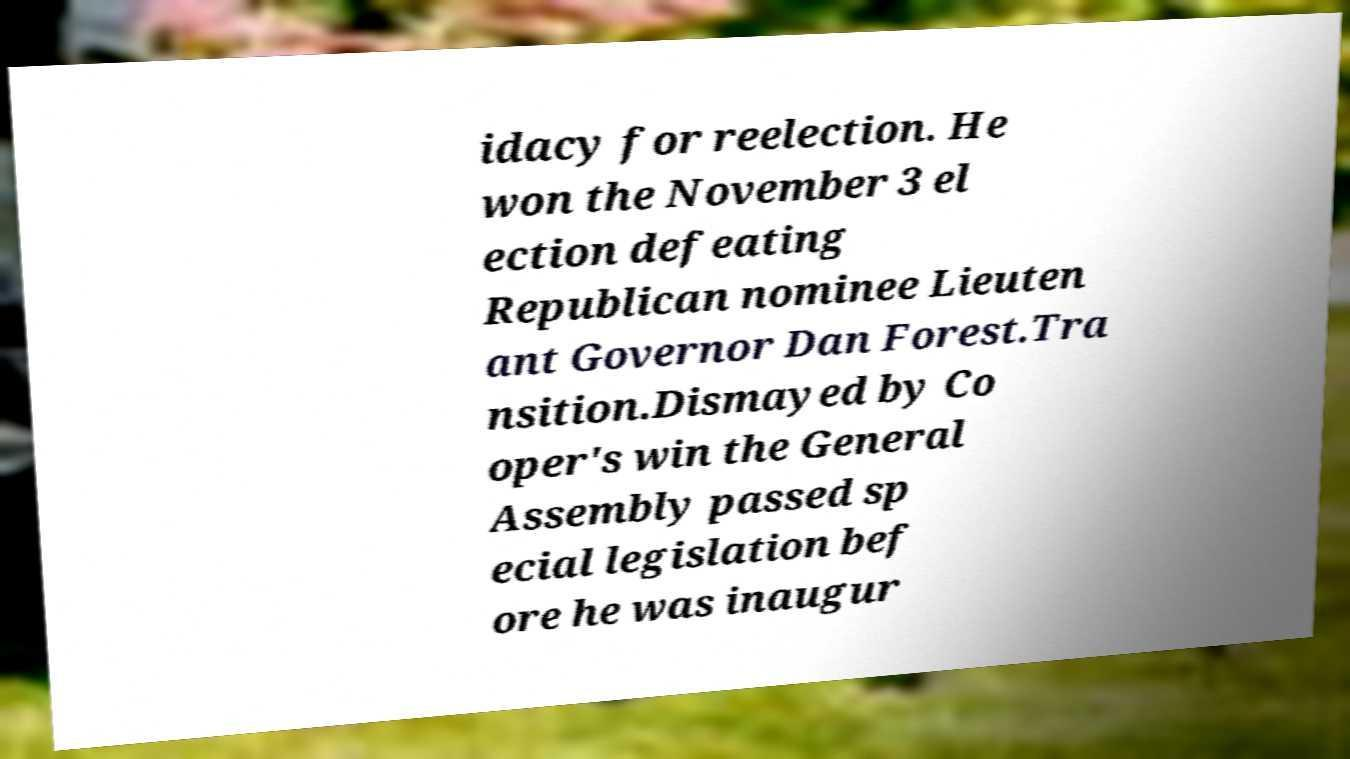What messages or text are displayed in this image? I need them in a readable, typed format. idacy for reelection. He won the November 3 el ection defeating Republican nominee Lieuten ant Governor Dan Forest.Tra nsition.Dismayed by Co oper's win the General Assembly passed sp ecial legislation bef ore he was inaugur 